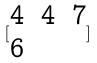<formula> <loc_0><loc_0><loc_500><loc_500>[ \begin{matrix} 4 & 4 & 7 \\ 6 \end{matrix} ]</formula> 